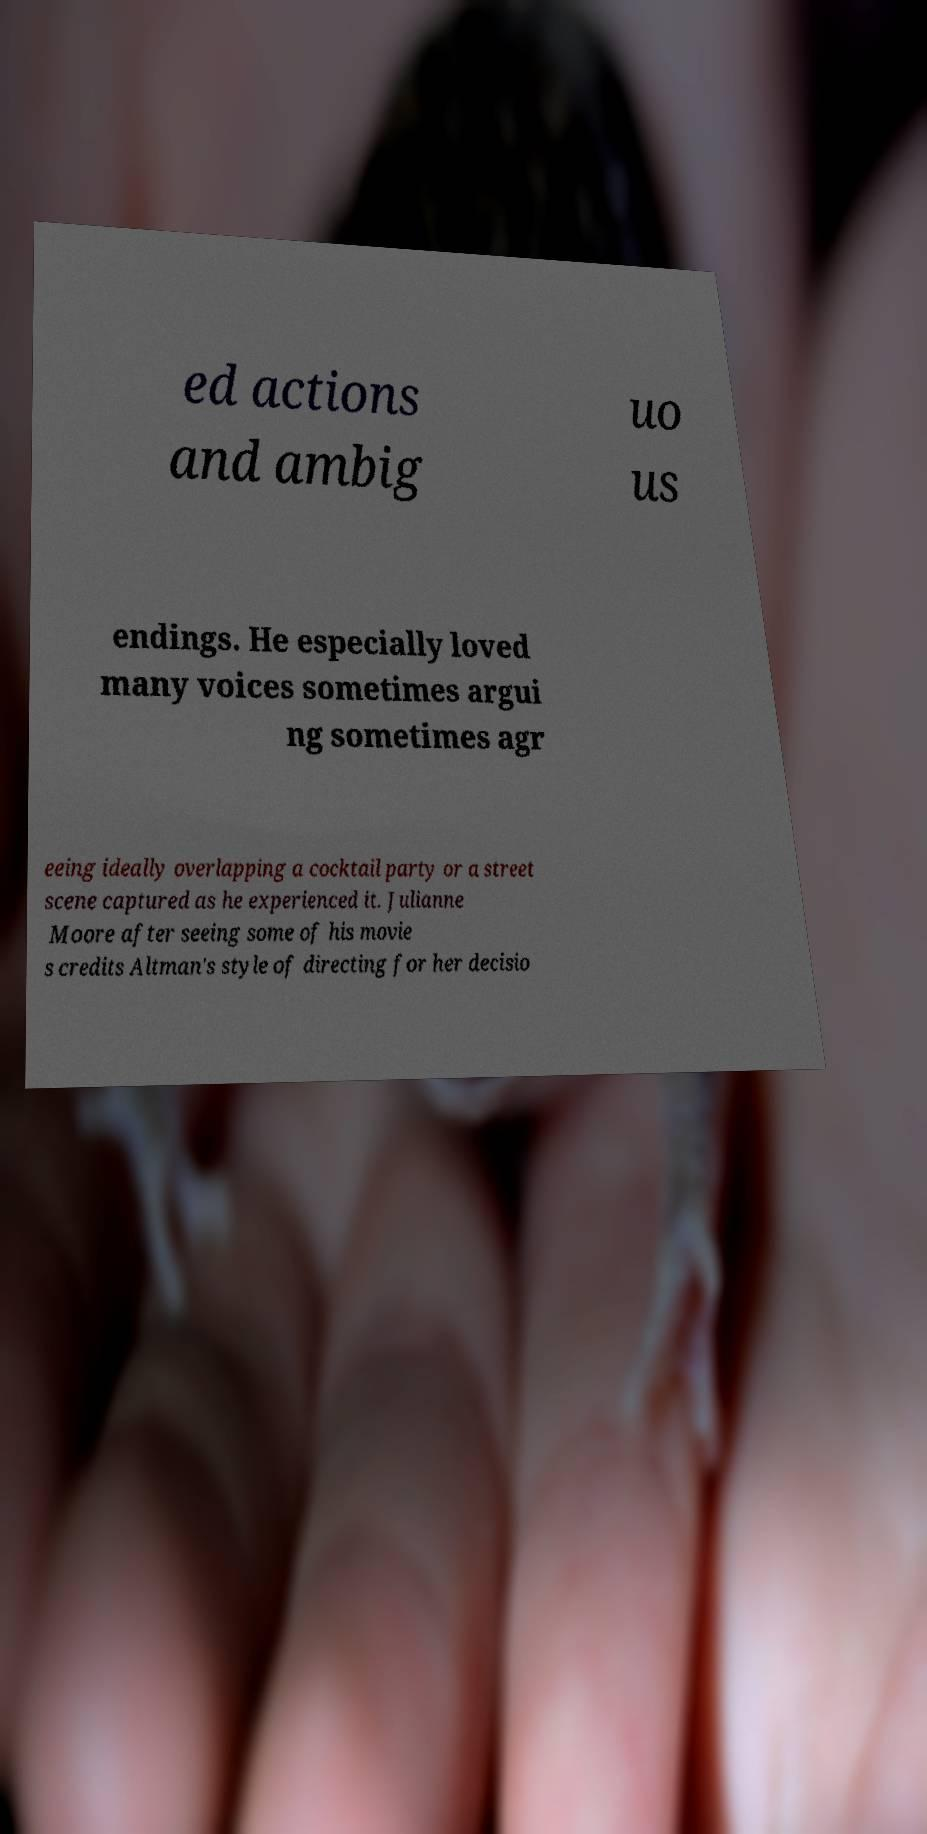Can you accurately transcribe the text from the provided image for me? ed actions and ambig uo us endings. He especially loved many voices sometimes argui ng sometimes agr eeing ideally overlapping a cocktail party or a street scene captured as he experienced it. Julianne Moore after seeing some of his movie s credits Altman's style of directing for her decisio 